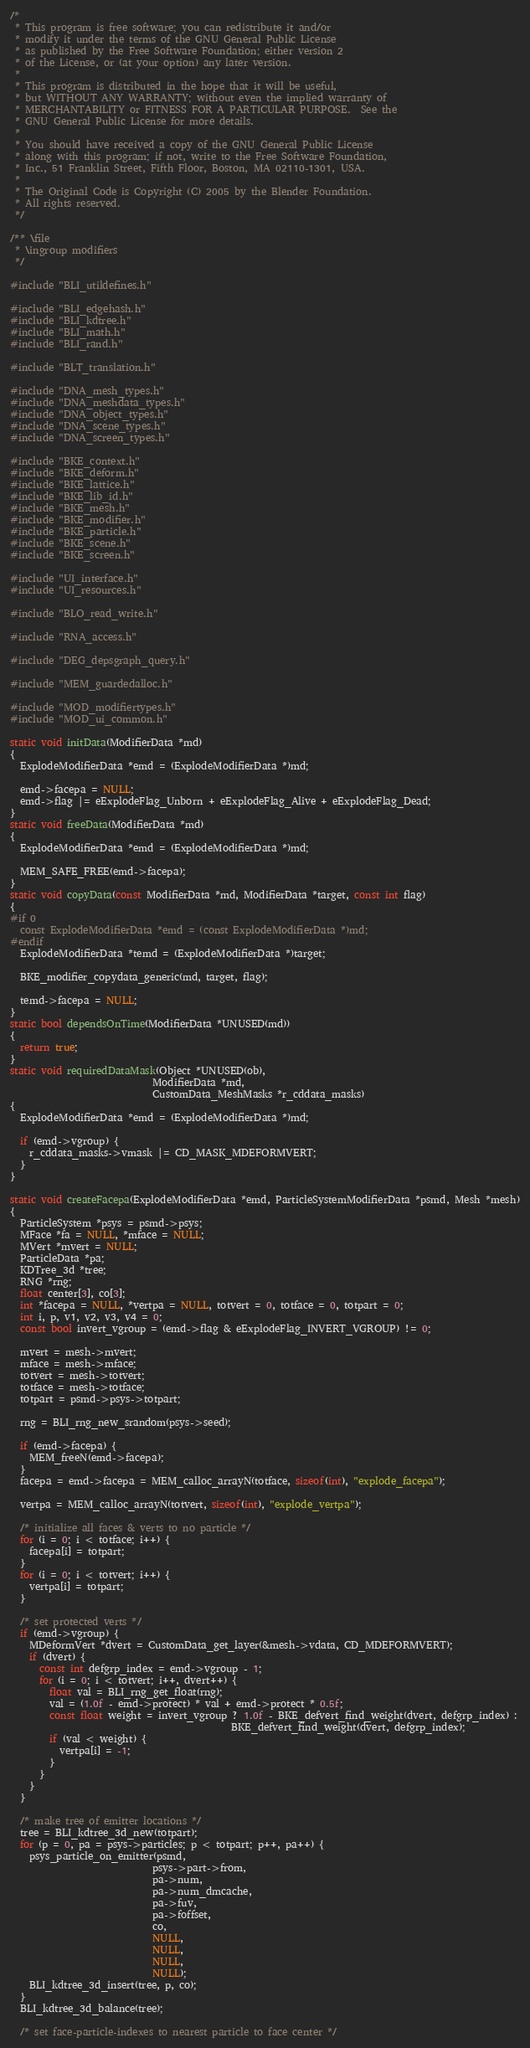Convert code to text. <code><loc_0><loc_0><loc_500><loc_500><_C_>/*
 * This program is free software; you can redistribute it and/or
 * modify it under the terms of the GNU General Public License
 * as published by the Free Software Foundation; either version 2
 * of the License, or (at your option) any later version.
 *
 * This program is distributed in the hope that it will be useful,
 * but WITHOUT ANY WARRANTY; without even the implied warranty of
 * MERCHANTABILITY or FITNESS FOR A PARTICULAR PURPOSE.  See the
 * GNU General Public License for more details.
 *
 * You should have received a copy of the GNU General Public License
 * along with this program; if not, write to the Free Software Foundation,
 * Inc., 51 Franklin Street, Fifth Floor, Boston, MA 02110-1301, USA.
 *
 * The Original Code is Copyright (C) 2005 by the Blender Foundation.
 * All rights reserved.
 */

/** \file
 * \ingroup modifiers
 */

#include "BLI_utildefines.h"

#include "BLI_edgehash.h"
#include "BLI_kdtree.h"
#include "BLI_math.h"
#include "BLI_rand.h"

#include "BLT_translation.h"

#include "DNA_mesh_types.h"
#include "DNA_meshdata_types.h"
#include "DNA_object_types.h"
#include "DNA_scene_types.h"
#include "DNA_screen_types.h"

#include "BKE_context.h"
#include "BKE_deform.h"
#include "BKE_lattice.h"
#include "BKE_lib_id.h"
#include "BKE_mesh.h"
#include "BKE_modifier.h"
#include "BKE_particle.h"
#include "BKE_scene.h"
#include "BKE_screen.h"

#include "UI_interface.h"
#include "UI_resources.h"

#include "BLO_read_write.h"

#include "RNA_access.h"

#include "DEG_depsgraph_query.h"

#include "MEM_guardedalloc.h"

#include "MOD_modifiertypes.h"
#include "MOD_ui_common.h"

static void initData(ModifierData *md)
{
  ExplodeModifierData *emd = (ExplodeModifierData *)md;

  emd->facepa = NULL;
  emd->flag |= eExplodeFlag_Unborn + eExplodeFlag_Alive + eExplodeFlag_Dead;
}
static void freeData(ModifierData *md)
{
  ExplodeModifierData *emd = (ExplodeModifierData *)md;

  MEM_SAFE_FREE(emd->facepa);
}
static void copyData(const ModifierData *md, ModifierData *target, const int flag)
{
#if 0
  const ExplodeModifierData *emd = (const ExplodeModifierData *)md;
#endif
  ExplodeModifierData *temd = (ExplodeModifierData *)target;

  BKE_modifier_copydata_generic(md, target, flag);

  temd->facepa = NULL;
}
static bool dependsOnTime(ModifierData *UNUSED(md))
{
  return true;
}
static void requiredDataMask(Object *UNUSED(ob),
                             ModifierData *md,
                             CustomData_MeshMasks *r_cddata_masks)
{
  ExplodeModifierData *emd = (ExplodeModifierData *)md;

  if (emd->vgroup) {
    r_cddata_masks->vmask |= CD_MASK_MDEFORMVERT;
  }
}

static void createFacepa(ExplodeModifierData *emd, ParticleSystemModifierData *psmd, Mesh *mesh)
{
  ParticleSystem *psys = psmd->psys;
  MFace *fa = NULL, *mface = NULL;
  MVert *mvert = NULL;
  ParticleData *pa;
  KDTree_3d *tree;
  RNG *rng;
  float center[3], co[3];
  int *facepa = NULL, *vertpa = NULL, totvert = 0, totface = 0, totpart = 0;
  int i, p, v1, v2, v3, v4 = 0;
  const bool invert_vgroup = (emd->flag & eExplodeFlag_INVERT_VGROUP) != 0;

  mvert = mesh->mvert;
  mface = mesh->mface;
  totvert = mesh->totvert;
  totface = mesh->totface;
  totpart = psmd->psys->totpart;

  rng = BLI_rng_new_srandom(psys->seed);

  if (emd->facepa) {
    MEM_freeN(emd->facepa);
  }
  facepa = emd->facepa = MEM_calloc_arrayN(totface, sizeof(int), "explode_facepa");

  vertpa = MEM_calloc_arrayN(totvert, sizeof(int), "explode_vertpa");

  /* initialize all faces & verts to no particle */
  for (i = 0; i < totface; i++) {
    facepa[i] = totpart;
  }
  for (i = 0; i < totvert; i++) {
    vertpa[i] = totpart;
  }

  /* set protected verts */
  if (emd->vgroup) {
    MDeformVert *dvert = CustomData_get_layer(&mesh->vdata, CD_MDEFORMVERT);
    if (dvert) {
      const int defgrp_index = emd->vgroup - 1;
      for (i = 0; i < totvert; i++, dvert++) {
        float val = BLI_rng_get_float(rng);
        val = (1.0f - emd->protect) * val + emd->protect * 0.5f;
        const float weight = invert_vgroup ? 1.0f - BKE_defvert_find_weight(dvert, defgrp_index) :
                                             BKE_defvert_find_weight(dvert, defgrp_index);
        if (val < weight) {
          vertpa[i] = -1;
        }
      }
    }
  }

  /* make tree of emitter locations */
  tree = BLI_kdtree_3d_new(totpart);
  for (p = 0, pa = psys->particles; p < totpart; p++, pa++) {
    psys_particle_on_emitter(psmd,
                             psys->part->from,
                             pa->num,
                             pa->num_dmcache,
                             pa->fuv,
                             pa->foffset,
                             co,
                             NULL,
                             NULL,
                             NULL,
                             NULL);
    BLI_kdtree_3d_insert(tree, p, co);
  }
  BLI_kdtree_3d_balance(tree);

  /* set face-particle-indexes to nearest particle to face center */</code> 